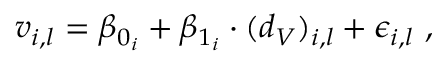<formula> <loc_0><loc_0><loc_500><loc_500>v _ { i , l } = \beta _ { 0 _ { i } } + \beta _ { 1 _ { i } } \cdot ( d _ { V } ) _ { i , l } + \epsilon _ { i , l } \ ,</formula> 